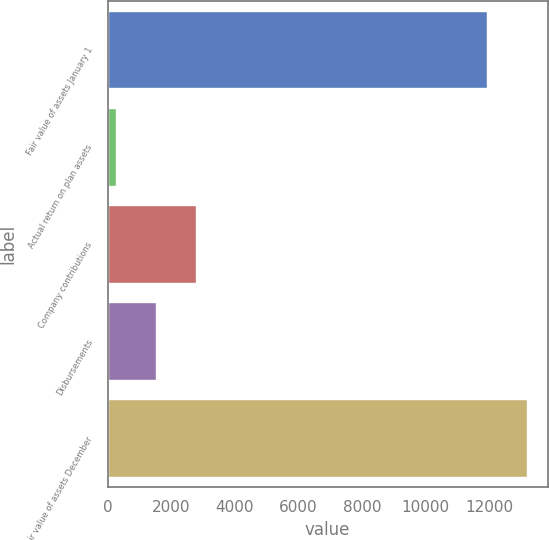Convert chart to OTSL. <chart><loc_0><loc_0><loc_500><loc_500><bar_chart><fcel>Fair value of assets January 1<fcel>Actual return on plan assets<fcel>Company contributions<fcel>Disbursements<fcel>Fair value of assets December<nl><fcel>11934<fcel>271<fcel>2776.4<fcel>1523.7<fcel>13186.7<nl></chart> 